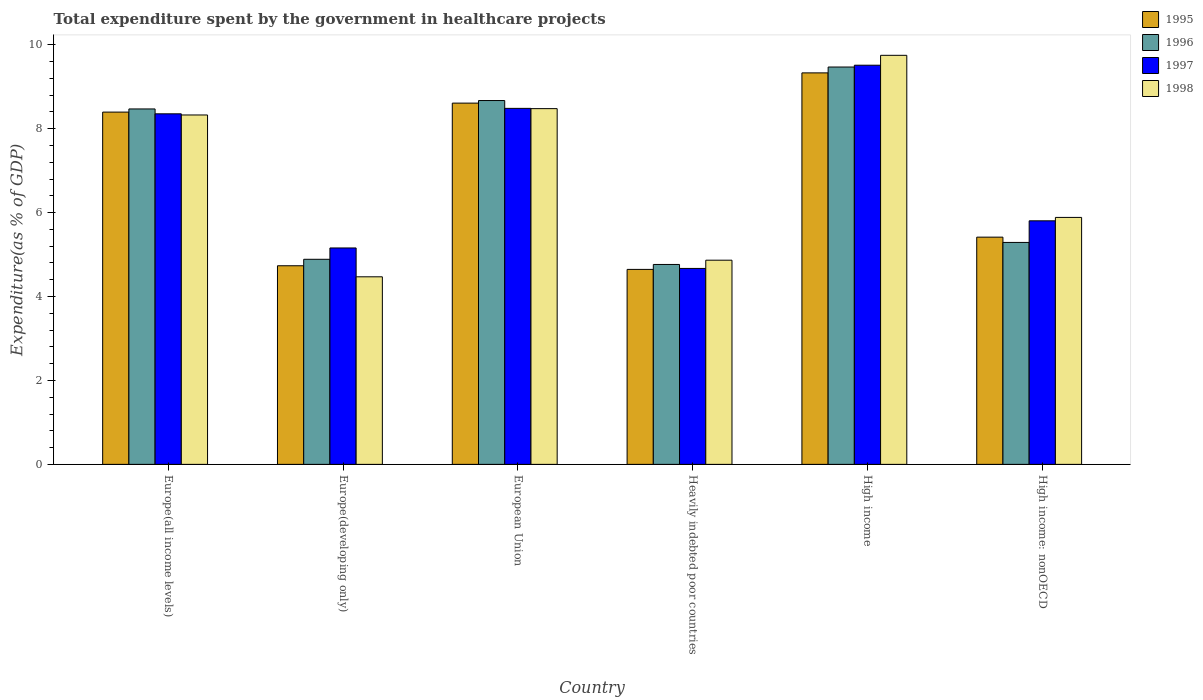How many bars are there on the 4th tick from the left?
Keep it short and to the point. 4. How many bars are there on the 2nd tick from the right?
Give a very brief answer. 4. What is the label of the 1st group of bars from the left?
Your answer should be compact. Europe(all income levels). In how many cases, is the number of bars for a given country not equal to the number of legend labels?
Your response must be concise. 0. What is the total expenditure spent by the government in healthcare projects in 1997 in High income?
Offer a terse response. 9.51. Across all countries, what is the maximum total expenditure spent by the government in healthcare projects in 1997?
Your response must be concise. 9.51. Across all countries, what is the minimum total expenditure spent by the government in healthcare projects in 1998?
Your answer should be compact. 4.47. In which country was the total expenditure spent by the government in healthcare projects in 1995 minimum?
Make the answer very short. Heavily indebted poor countries. What is the total total expenditure spent by the government in healthcare projects in 1998 in the graph?
Your answer should be very brief. 41.77. What is the difference between the total expenditure spent by the government in healthcare projects in 1998 in Europe(developing only) and that in High income: nonOECD?
Provide a succinct answer. -1.42. What is the difference between the total expenditure spent by the government in healthcare projects in 1997 in Europe(all income levels) and the total expenditure spent by the government in healthcare projects in 1995 in Europe(developing only)?
Give a very brief answer. 3.62. What is the average total expenditure spent by the government in healthcare projects in 1998 per country?
Your response must be concise. 6.96. What is the difference between the total expenditure spent by the government in healthcare projects of/in 1996 and total expenditure spent by the government in healthcare projects of/in 1997 in Europe(all income levels)?
Your answer should be very brief. 0.12. What is the ratio of the total expenditure spent by the government in healthcare projects in 1995 in Heavily indebted poor countries to that in High income: nonOECD?
Your response must be concise. 0.86. Is the difference between the total expenditure spent by the government in healthcare projects in 1996 in High income and High income: nonOECD greater than the difference between the total expenditure spent by the government in healthcare projects in 1997 in High income and High income: nonOECD?
Provide a short and direct response. Yes. What is the difference between the highest and the second highest total expenditure spent by the government in healthcare projects in 1998?
Keep it short and to the point. -1.27. What is the difference between the highest and the lowest total expenditure spent by the government in healthcare projects in 1997?
Your answer should be compact. 4.84. In how many countries, is the total expenditure spent by the government in healthcare projects in 1995 greater than the average total expenditure spent by the government in healthcare projects in 1995 taken over all countries?
Your response must be concise. 3. Is it the case that in every country, the sum of the total expenditure spent by the government in healthcare projects in 1995 and total expenditure spent by the government in healthcare projects in 1997 is greater than the sum of total expenditure spent by the government in healthcare projects in 1996 and total expenditure spent by the government in healthcare projects in 1998?
Offer a terse response. No. Is it the case that in every country, the sum of the total expenditure spent by the government in healthcare projects in 1998 and total expenditure spent by the government in healthcare projects in 1996 is greater than the total expenditure spent by the government in healthcare projects in 1997?
Make the answer very short. Yes. How many bars are there?
Your answer should be compact. 24. Does the graph contain any zero values?
Keep it short and to the point. No. Does the graph contain grids?
Make the answer very short. No. Where does the legend appear in the graph?
Give a very brief answer. Top right. How are the legend labels stacked?
Make the answer very short. Vertical. What is the title of the graph?
Your response must be concise. Total expenditure spent by the government in healthcare projects. Does "1982" appear as one of the legend labels in the graph?
Your answer should be compact. No. What is the label or title of the X-axis?
Keep it short and to the point. Country. What is the label or title of the Y-axis?
Ensure brevity in your answer.  Expenditure(as % of GDP). What is the Expenditure(as % of GDP) in 1995 in Europe(all income levels)?
Offer a terse response. 8.39. What is the Expenditure(as % of GDP) of 1996 in Europe(all income levels)?
Provide a short and direct response. 8.47. What is the Expenditure(as % of GDP) in 1997 in Europe(all income levels)?
Provide a succinct answer. 8.35. What is the Expenditure(as % of GDP) of 1998 in Europe(all income levels)?
Ensure brevity in your answer.  8.33. What is the Expenditure(as % of GDP) in 1995 in Europe(developing only)?
Offer a very short reply. 4.73. What is the Expenditure(as % of GDP) in 1996 in Europe(developing only)?
Offer a terse response. 4.89. What is the Expenditure(as % of GDP) in 1997 in Europe(developing only)?
Offer a very short reply. 5.16. What is the Expenditure(as % of GDP) in 1998 in Europe(developing only)?
Your answer should be compact. 4.47. What is the Expenditure(as % of GDP) of 1995 in European Union?
Keep it short and to the point. 8.61. What is the Expenditure(as % of GDP) in 1996 in European Union?
Give a very brief answer. 8.67. What is the Expenditure(as % of GDP) of 1997 in European Union?
Give a very brief answer. 8.48. What is the Expenditure(as % of GDP) in 1998 in European Union?
Your answer should be compact. 8.48. What is the Expenditure(as % of GDP) in 1995 in Heavily indebted poor countries?
Provide a short and direct response. 4.65. What is the Expenditure(as % of GDP) in 1996 in Heavily indebted poor countries?
Give a very brief answer. 4.76. What is the Expenditure(as % of GDP) in 1997 in Heavily indebted poor countries?
Offer a terse response. 4.67. What is the Expenditure(as % of GDP) of 1998 in Heavily indebted poor countries?
Keep it short and to the point. 4.87. What is the Expenditure(as % of GDP) in 1995 in High income?
Your response must be concise. 9.33. What is the Expenditure(as % of GDP) in 1996 in High income?
Provide a succinct answer. 9.47. What is the Expenditure(as % of GDP) of 1997 in High income?
Provide a short and direct response. 9.51. What is the Expenditure(as % of GDP) of 1998 in High income?
Your answer should be compact. 9.75. What is the Expenditure(as % of GDP) in 1995 in High income: nonOECD?
Keep it short and to the point. 5.41. What is the Expenditure(as % of GDP) in 1996 in High income: nonOECD?
Keep it short and to the point. 5.29. What is the Expenditure(as % of GDP) of 1997 in High income: nonOECD?
Provide a short and direct response. 5.8. What is the Expenditure(as % of GDP) of 1998 in High income: nonOECD?
Your answer should be compact. 5.88. Across all countries, what is the maximum Expenditure(as % of GDP) of 1995?
Your answer should be compact. 9.33. Across all countries, what is the maximum Expenditure(as % of GDP) of 1996?
Provide a succinct answer. 9.47. Across all countries, what is the maximum Expenditure(as % of GDP) of 1997?
Give a very brief answer. 9.51. Across all countries, what is the maximum Expenditure(as % of GDP) of 1998?
Provide a short and direct response. 9.75. Across all countries, what is the minimum Expenditure(as % of GDP) of 1995?
Offer a very short reply. 4.65. Across all countries, what is the minimum Expenditure(as % of GDP) in 1996?
Ensure brevity in your answer.  4.76. Across all countries, what is the minimum Expenditure(as % of GDP) in 1997?
Provide a succinct answer. 4.67. Across all countries, what is the minimum Expenditure(as % of GDP) in 1998?
Your response must be concise. 4.47. What is the total Expenditure(as % of GDP) in 1995 in the graph?
Give a very brief answer. 41.13. What is the total Expenditure(as % of GDP) of 1996 in the graph?
Your response must be concise. 41.55. What is the total Expenditure(as % of GDP) in 1997 in the graph?
Give a very brief answer. 41.98. What is the total Expenditure(as % of GDP) in 1998 in the graph?
Provide a succinct answer. 41.77. What is the difference between the Expenditure(as % of GDP) of 1995 in Europe(all income levels) and that in Europe(developing only)?
Ensure brevity in your answer.  3.66. What is the difference between the Expenditure(as % of GDP) in 1996 in Europe(all income levels) and that in Europe(developing only)?
Make the answer very short. 3.58. What is the difference between the Expenditure(as % of GDP) in 1997 in Europe(all income levels) and that in Europe(developing only)?
Provide a short and direct response. 3.2. What is the difference between the Expenditure(as % of GDP) in 1998 in Europe(all income levels) and that in Europe(developing only)?
Make the answer very short. 3.86. What is the difference between the Expenditure(as % of GDP) in 1995 in Europe(all income levels) and that in European Union?
Offer a very short reply. -0.21. What is the difference between the Expenditure(as % of GDP) of 1996 in Europe(all income levels) and that in European Union?
Keep it short and to the point. -0.2. What is the difference between the Expenditure(as % of GDP) in 1997 in Europe(all income levels) and that in European Union?
Your answer should be compact. -0.13. What is the difference between the Expenditure(as % of GDP) of 1998 in Europe(all income levels) and that in European Union?
Ensure brevity in your answer.  -0.15. What is the difference between the Expenditure(as % of GDP) of 1995 in Europe(all income levels) and that in Heavily indebted poor countries?
Make the answer very short. 3.75. What is the difference between the Expenditure(as % of GDP) of 1996 in Europe(all income levels) and that in Heavily indebted poor countries?
Your response must be concise. 3.71. What is the difference between the Expenditure(as % of GDP) in 1997 in Europe(all income levels) and that in Heavily indebted poor countries?
Provide a succinct answer. 3.68. What is the difference between the Expenditure(as % of GDP) in 1998 in Europe(all income levels) and that in Heavily indebted poor countries?
Ensure brevity in your answer.  3.46. What is the difference between the Expenditure(as % of GDP) in 1995 in Europe(all income levels) and that in High income?
Your answer should be compact. -0.93. What is the difference between the Expenditure(as % of GDP) in 1996 in Europe(all income levels) and that in High income?
Give a very brief answer. -1. What is the difference between the Expenditure(as % of GDP) in 1997 in Europe(all income levels) and that in High income?
Ensure brevity in your answer.  -1.16. What is the difference between the Expenditure(as % of GDP) in 1998 in Europe(all income levels) and that in High income?
Provide a short and direct response. -1.42. What is the difference between the Expenditure(as % of GDP) of 1995 in Europe(all income levels) and that in High income: nonOECD?
Offer a terse response. 2.98. What is the difference between the Expenditure(as % of GDP) in 1996 in Europe(all income levels) and that in High income: nonOECD?
Your response must be concise. 3.18. What is the difference between the Expenditure(as % of GDP) in 1997 in Europe(all income levels) and that in High income: nonOECD?
Your answer should be very brief. 2.55. What is the difference between the Expenditure(as % of GDP) in 1998 in Europe(all income levels) and that in High income: nonOECD?
Provide a succinct answer. 2.44. What is the difference between the Expenditure(as % of GDP) of 1995 in Europe(developing only) and that in European Union?
Your response must be concise. -3.88. What is the difference between the Expenditure(as % of GDP) in 1996 in Europe(developing only) and that in European Union?
Keep it short and to the point. -3.78. What is the difference between the Expenditure(as % of GDP) of 1997 in Europe(developing only) and that in European Union?
Give a very brief answer. -3.33. What is the difference between the Expenditure(as % of GDP) in 1998 in Europe(developing only) and that in European Union?
Offer a terse response. -4.01. What is the difference between the Expenditure(as % of GDP) of 1995 in Europe(developing only) and that in Heavily indebted poor countries?
Give a very brief answer. 0.09. What is the difference between the Expenditure(as % of GDP) in 1996 in Europe(developing only) and that in Heavily indebted poor countries?
Provide a short and direct response. 0.12. What is the difference between the Expenditure(as % of GDP) in 1997 in Europe(developing only) and that in Heavily indebted poor countries?
Your response must be concise. 0.49. What is the difference between the Expenditure(as % of GDP) in 1998 in Europe(developing only) and that in Heavily indebted poor countries?
Your response must be concise. -0.4. What is the difference between the Expenditure(as % of GDP) in 1995 in Europe(developing only) and that in High income?
Make the answer very short. -4.6. What is the difference between the Expenditure(as % of GDP) in 1996 in Europe(developing only) and that in High income?
Offer a terse response. -4.58. What is the difference between the Expenditure(as % of GDP) of 1997 in Europe(developing only) and that in High income?
Provide a succinct answer. -4.35. What is the difference between the Expenditure(as % of GDP) of 1998 in Europe(developing only) and that in High income?
Your response must be concise. -5.28. What is the difference between the Expenditure(as % of GDP) in 1995 in Europe(developing only) and that in High income: nonOECD?
Your response must be concise. -0.68. What is the difference between the Expenditure(as % of GDP) of 1996 in Europe(developing only) and that in High income: nonOECD?
Offer a terse response. -0.4. What is the difference between the Expenditure(as % of GDP) of 1997 in Europe(developing only) and that in High income: nonOECD?
Keep it short and to the point. -0.65. What is the difference between the Expenditure(as % of GDP) in 1998 in Europe(developing only) and that in High income: nonOECD?
Your answer should be compact. -1.42. What is the difference between the Expenditure(as % of GDP) of 1995 in European Union and that in Heavily indebted poor countries?
Give a very brief answer. 3.96. What is the difference between the Expenditure(as % of GDP) of 1996 in European Union and that in Heavily indebted poor countries?
Your answer should be compact. 3.91. What is the difference between the Expenditure(as % of GDP) of 1997 in European Union and that in Heavily indebted poor countries?
Your response must be concise. 3.81. What is the difference between the Expenditure(as % of GDP) of 1998 in European Union and that in Heavily indebted poor countries?
Make the answer very short. 3.61. What is the difference between the Expenditure(as % of GDP) of 1995 in European Union and that in High income?
Your answer should be very brief. -0.72. What is the difference between the Expenditure(as % of GDP) in 1996 in European Union and that in High income?
Your response must be concise. -0.8. What is the difference between the Expenditure(as % of GDP) in 1997 in European Union and that in High income?
Provide a short and direct response. -1.03. What is the difference between the Expenditure(as % of GDP) in 1998 in European Union and that in High income?
Make the answer very short. -1.27. What is the difference between the Expenditure(as % of GDP) in 1995 in European Union and that in High income: nonOECD?
Make the answer very short. 3.19. What is the difference between the Expenditure(as % of GDP) of 1996 in European Union and that in High income: nonOECD?
Offer a very short reply. 3.38. What is the difference between the Expenditure(as % of GDP) of 1997 in European Union and that in High income: nonOECD?
Give a very brief answer. 2.68. What is the difference between the Expenditure(as % of GDP) in 1998 in European Union and that in High income: nonOECD?
Provide a short and direct response. 2.59. What is the difference between the Expenditure(as % of GDP) in 1995 in Heavily indebted poor countries and that in High income?
Your answer should be very brief. -4.68. What is the difference between the Expenditure(as % of GDP) of 1996 in Heavily indebted poor countries and that in High income?
Offer a terse response. -4.7. What is the difference between the Expenditure(as % of GDP) in 1997 in Heavily indebted poor countries and that in High income?
Ensure brevity in your answer.  -4.84. What is the difference between the Expenditure(as % of GDP) in 1998 in Heavily indebted poor countries and that in High income?
Your answer should be compact. -4.88. What is the difference between the Expenditure(as % of GDP) of 1995 in Heavily indebted poor countries and that in High income: nonOECD?
Your answer should be very brief. -0.77. What is the difference between the Expenditure(as % of GDP) of 1996 in Heavily indebted poor countries and that in High income: nonOECD?
Provide a succinct answer. -0.53. What is the difference between the Expenditure(as % of GDP) of 1997 in Heavily indebted poor countries and that in High income: nonOECD?
Your answer should be very brief. -1.13. What is the difference between the Expenditure(as % of GDP) of 1998 in Heavily indebted poor countries and that in High income: nonOECD?
Offer a very short reply. -1.02. What is the difference between the Expenditure(as % of GDP) of 1995 in High income and that in High income: nonOECD?
Provide a succinct answer. 3.91. What is the difference between the Expenditure(as % of GDP) in 1996 in High income and that in High income: nonOECD?
Your answer should be compact. 4.18. What is the difference between the Expenditure(as % of GDP) of 1997 in High income and that in High income: nonOECD?
Your answer should be compact. 3.71. What is the difference between the Expenditure(as % of GDP) in 1998 in High income and that in High income: nonOECD?
Give a very brief answer. 3.86. What is the difference between the Expenditure(as % of GDP) of 1995 in Europe(all income levels) and the Expenditure(as % of GDP) of 1996 in Europe(developing only)?
Offer a terse response. 3.51. What is the difference between the Expenditure(as % of GDP) in 1995 in Europe(all income levels) and the Expenditure(as % of GDP) in 1997 in Europe(developing only)?
Make the answer very short. 3.24. What is the difference between the Expenditure(as % of GDP) in 1995 in Europe(all income levels) and the Expenditure(as % of GDP) in 1998 in Europe(developing only)?
Ensure brevity in your answer.  3.92. What is the difference between the Expenditure(as % of GDP) in 1996 in Europe(all income levels) and the Expenditure(as % of GDP) in 1997 in Europe(developing only)?
Provide a succinct answer. 3.31. What is the difference between the Expenditure(as % of GDP) in 1996 in Europe(all income levels) and the Expenditure(as % of GDP) in 1998 in Europe(developing only)?
Provide a succinct answer. 4. What is the difference between the Expenditure(as % of GDP) in 1997 in Europe(all income levels) and the Expenditure(as % of GDP) in 1998 in Europe(developing only)?
Your response must be concise. 3.88. What is the difference between the Expenditure(as % of GDP) in 1995 in Europe(all income levels) and the Expenditure(as % of GDP) in 1996 in European Union?
Provide a succinct answer. -0.28. What is the difference between the Expenditure(as % of GDP) of 1995 in Europe(all income levels) and the Expenditure(as % of GDP) of 1997 in European Union?
Provide a short and direct response. -0.09. What is the difference between the Expenditure(as % of GDP) in 1995 in Europe(all income levels) and the Expenditure(as % of GDP) in 1998 in European Union?
Provide a short and direct response. -0.08. What is the difference between the Expenditure(as % of GDP) of 1996 in Europe(all income levels) and the Expenditure(as % of GDP) of 1997 in European Union?
Your answer should be very brief. -0.01. What is the difference between the Expenditure(as % of GDP) in 1996 in Europe(all income levels) and the Expenditure(as % of GDP) in 1998 in European Union?
Ensure brevity in your answer.  -0.01. What is the difference between the Expenditure(as % of GDP) of 1997 in Europe(all income levels) and the Expenditure(as % of GDP) of 1998 in European Union?
Ensure brevity in your answer.  -0.12. What is the difference between the Expenditure(as % of GDP) in 1995 in Europe(all income levels) and the Expenditure(as % of GDP) in 1996 in Heavily indebted poor countries?
Ensure brevity in your answer.  3.63. What is the difference between the Expenditure(as % of GDP) in 1995 in Europe(all income levels) and the Expenditure(as % of GDP) in 1997 in Heavily indebted poor countries?
Your response must be concise. 3.73. What is the difference between the Expenditure(as % of GDP) in 1995 in Europe(all income levels) and the Expenditure(as % of GDP) in 1998 in Heavily indebted poor countries?
Provide a short and direct response. 3.53. What is the difference between the Expenditure(as % of GDP) in 1996 in Europe(all income levels) and the Expenditure(as % of GDP) in 1997 in Heavily indebted poor countries?
Provide a succinct answer. 3.8. What is the difference between the Expenditure(as % of GDP) in 1996 in Europe(all income levels) and the Expenditure(as % of GDP) in 1998 in Heavily indebted poor countries?
Provide a short and direct response. 3.6. What is the difference between the Expenditure(as % of GDP) in 1997 in Europe(all income levels) and the Expenditure(as % of GDP) in 1998 in Heavily indebted poor countries?
Make the answer very short. 3.49. What is the difference between the Expenditure(as % of GDP) of 1995 in Europe(all income levels) and the Expenditure(as % of GDP) of 1996 in High income?
Your response must be concise. -1.07. What is the difference between the Expenditure(as % of GDP) of 1995 in Europe(all income levels) and the Expenditure(as % of GDP) of 1997 in High income?
Offer a terse response. -1.12. What is the difference between the Expenditure(as % of GDP) of 1995 in Europe(all income levels) and the Expenditure(as % of GDP) of 1998 in High income?
Ensure brevity in your answer.  -1.35. What is the difference between the Expenditure(as % of GDP) of 1996 in Europe(all income levels) and the Expenditure(as % of GDP) of 1997 in High income?
Offer a very short reply. -1.04. What is the difference between the Expenditure(as % of GDP) of 1996 in Europe(all income levels) and the Expenditure(as % of GDP) of 1998 in High income?
Provide a short and direct response. -1.28. What is the difference between the Expenditure(as % of GDP) in 1997 in Europe(all income levels) and the Expenditure(as % of GDP) in 1998 in High income?
Offer a very short reply. -1.39. What is the difference between the Expenditure(as % of GDP) in 1995 in Europe(all income levels) and the Expenditure(as % of GDP) in 1996 in High income: nonOECD?
Offer a very short reply. 3.11. What is the difference between the Expenditure(as % of GDP) of 1995 in Europe(all income levels) and the Expenditure(as % of GDP) of 1997 in High income: nonOECD?
Provide a succinct answer. 2.59. What is the difference between the Expenditure(as % of GDP) in 1995 in Europe(all income levels) and the Expenditure(as % of GDP) in 1998 in High income: nonOECD?
Offer a very short reply. 2.51. What is the difference between the Expenditure(as % of GDP) in 1996 in Europe(all income levels) and the Expenditure(as % of GDP) in 1997 in High income: nonOECD?
Offer a very short reply. 2.67. What is the difference between the Expenditure(as % of GDP) of 1996 in Europe(all income levels) and the Expenditure(as % of GDP) of 1998 in High income: nonOECD?
Give a very brief answer. 2.58. What is the difference between the Expenditure(as % of GDP) in 1997 in Europe(all income levels) and the Expenditure(as % of GDP) in 1998 in High income: nonOECD?
Ensure brevity in your answer.  2.47. What is the difference between the Expenditure(as % of GDP) of 1995 in Europe(developing only) and the Expenditure(as % of GDP) of 1996 in European Union?
Your answer should be compact. -3.94. What is the difference between the Expenditure(as % of GDP) of 1995 in Europe(developing only) and the Expenditure(as % of GDP) of 1997 in European Union?
Provide a succinct answer. -3.75. What is the difference between the Expenditure(as % of GDP) of 1995 in Europe(developing only) and the Expenditure(as % of GDP) of 1998 in European Union?
Offer a terse response. -3.74. What is the difference between the Expenditure(as % of GDP) in 1996 in Europe(developing only) and the Expenditure(as % of GDP) in 1997 in European Union?
Offer a terse response. -3.6. What is the difference between the Expenditure(as % of GDP) in 1996 in Europe(developing only) and the Expenditure(as % of GDP) in 1998 in European Union?
Provide a succinct answer. -3.59. What is the difference between the Expenditure(as % of GDP) in 1997 in Europe(developing only) and the Expenditure(as % of GDP) in 1998 in European Union?
Your answer should be compact. -3.32. What is the difference between the Expenditure(as % of GDP) of 1995 in Europe(developing only) and the Expenditure(as % of GDP) of 1996 in Heavily indebted poor countries?
Your answer should be compact. -0.03. What is the difference between the Expenditure(as % of GDP) of 1995 in Europe(developing only) and the Expenditure(as % of GDP) of 1997 in Heavily indebted poor countries?
Your response must be concise. 0.06. What is the difference between the Expenditure(as % of GDP) of 1995 in Europe(developing only) and the Expenditure(as % of GDP) of 1998 in Heavily indebted poor countries?
Offer a very short reply. -0.13. What is the difference between the Expenditure(as % of GDP) of 1996 in Europe(developing only) and the Expenditure(as % of GDP) of 1997 in Heavily indebted poor countries?
Your answer should be compact. 0.22. What is the difference between the Expenditure(as % of GDP) of 1996 in Europe(developing only) and the Expenditure(as % of GDP) of 1998 in Heavily indebted poor countries?
Your answer should be very brief. 0.02. What is the difference between the Expenditure(as % of GDP) in 1997 in Europe(developing only) and the Expenditure(as % of GDP) in 1998 in Heavily indebted poor countries?
Provide a short and direct response. 0.29. What is the difference between the Expenditure(as % of GDP) of 1995 in Europe(developing only) and the Expenditure(as % of GDP) of 1996 in High income?
Make the answer very short. -4.74. What is the difference between the Expenditure(as % of GDP) in 1995 in Europe(developing only) and the Expenditure(as % of GDP) in 1997 in High income?
Make the answer very short. -4.78. What is the difference between the Expenditure(as % of GDP) in 1995 in Europe(developing only) and the Expenditure(as % of GDP) in 1998 in High income?
Your response must be concise. -5.01. What is the difference between the Expenditure(as % of GDP) of 1996 in Europe(developing only) and the Expenditure(as % of GDP) of 1997 in High income?
Your answer should be very brief. -4.62. What is the difference between the Expenditure(as % of GDP) of 1996 in Europe(developing only) and the Expenditure(as % of GDP) of 1998 in High income?
Ensure brevity in your answer.  -4.86. What is the difference between the Expenditure(as % of GDP) in 1997 in Europe(developing only) and the Expenditure(as % of GDP) in 1998 in High income?
Keep it short and to the point. -4.59. What is the difference between the Expenditure(as % of GDP) of 1995 in Europe(developing only) and the Expenditure(as % of GDP) of 1996 in High income: nonOECD?
Provide a short and direct response. -0.56. What is the difference between the Expenditure(as % of GDP) of 1995 in Europe(developing only) and the Expenditure(as % of GDP) of 1997 in High income: nonOECD?
Give a very brief answer. -1.07. What is the difference between the Expenditure(as % of GDP) in 1995 in Europe(developing only) and the Expenditure(as % of GDP) in 1998 in High income: nonOECD?
Provide a succinct answer. -1.15. What is the difference between the Expenditure(as % of GDP) of 1996 in Europe(developing only) and the Expenditure(as % of GDP) of 1997 in High income: nonOECD?
Your answer should be very brief. -0.92. What is the difference between the Expenditure(as % of GDP) of 1996 in Europe(developing only) and the Expenditure(as % of GDP) of 1998 in High income: nonOECD?
Keep it short and to the point. -1. What is the difference between the Expenditure(as % of GDP) in 1997 in Europe(developing only) and the Expenditure(as % of GDP) in 1998 in High income: nonOECD?
Provide a succinct answer. -0.73. What is the difference between the Expenditure(as % of GDP) in 1995 in European Union and the Expenditure(as % of GDP) in 1996 in Heavily indebted poor countries?
Provide a short and direct response. 3.84. What is the difference between the Expenditure(as % of GDP) in 1995 in European Union and the Expenditure(as % of GDP) in 1997 in Heavily indebted poor countries?
Offer a very short reply. 3.94. What is the difference between the Expenditure(as % of GDP) in 1995 in European Union and the Expenditure(as % of GDP) in 1998 in Heavily indebted poor countries?
Ensure brevity in your answer.  3.74. What is the difference between the Expenditure(as % of GDP) of 1996 in European Union and the Expenditure(as % of GDP) of 1997 in Heavily indebted poor countries?
Provide a succinct answer. 4. What is the difference between the Expenditure(as % of GDP) in 1996 in European Union and the Expenditure(as % of GDP) in 1998 in Heavily indebted poor countries?
Give a very brief answer. 3.8. What is the difference between the Expenditure(as % of GDP) of 1997 in European Union and the Expenditure(as % of GDP) of 1998 in Heavily indebted poor countries?
Provide a succinct answer. 3.62. What is the difference between the Expenditure(as % of GDP) in 1995 in European Union and the Expenditure(as % of GDP) in 1996 in High income?
Your answer should be compact. -0.86. What is the difference between the Expenditure(as % of GDP) of 1995 in European Union and the Expenditure(as % of GDP) of 1997 in High income?
Provide a succinct answer. -0.9. What is the difference between the Expenditure(as % of GDP) in 1995 in European Union and the Expenditure(as % of GDP) in 1998 in High income?
Your response must be concise. -1.14. What is the difference between the Expenditure(as % of GDP) of 1996 in European Union and the Expenditure(as % of GDP) of 1997 in High income?
Provide a short and direct response. -0.84. What is the difference between the Expenditure(as % of GDP) of 1996 in European Union and the Expenditure(as % of GDP) of 1998 in High income?
Ensure brevity in your answer.  -1.08. What is the difference between the Expenditure(as % of GDP) in 1997 in European Union and the Expenditure(as % of GDP) in 1998 in High income?
Make the answer very short. -1.26. What is the difference between the Expenditure(as % of GDP) of 1995 in European Union and the Expenditure(as % of GDP) of 1996 in High income: nonOECD?
Make the answer very short. 3.32. What is the difference between the Expenditure(as % of GDP) in 1995 in European Union and the Expenditure(as % of GDP) in 1997 in High income: nonOECD?
Ensure brevity in your answer.  2.8. What is the difference between the Expenditure(as % of GDP) in 1995 in European Union and the Expenditure(as % of GDP) in 1998 in High income: nonOECD?
Offer a terse response. 2.72. What is the difference between the Expenditure(as % of GDP) of 1996 in European Union and the Expenditure(as % of GDP) of 1997 in High income: nonOECD?
Offer a terse response. 2.87. What is the difference between the Expenditure(as % of GDP) of 1996 in European Union and the Expenditure(as % of GDP) of 1998 in High income: nonOECD?
Your answer should be compact. 2.79. What is the difference between the Expenditure(as % of GDP) of 1997 in European Union and the Expenditure(as % of GDP) of 1998 in High income: nonOECD?
Your response must be concise. 2.6. What is the difference between the Expenditure(as % of GDP) in 1995 in Heavily indebted poor countries and the Expenditure(as % of GDP) in 1996 in High income?
Offer a very short reply. -4.82. What is the difference between the Expenditure(as % of GDP) in 1995 in Heavily indebted poor countries and the Expenditure(as % of GDP) in 1997 in High income?
Your answer should be compact. -4.87. What is the difference between the Expenditure(as % of GDP) in 1995 in Heavily indebted poor countries and the Expenditure(as % of GDP) in 1998 in High income?
Keep it short and to the point. -5.1. What is the difference between the Expenditure(as % of GDP) in 1996 in Heavily indebted poor countries and the Expenditure(as % of GDP) in 1997 in High income?
Give a very brief answer. -4.75. What is the difference between the Expenditure(as % of GDP) in 1996 in Heavily indebted poor countries and the Expenditure(as % of GDP) in 1998 in High income?
Ensure brevity in your answer.  -4.98. What is the difference between the Expenditure(as % of GDP) in 1997 in Heavily indebted poor countries and the Expenditure(as % of GDP) in 1998 in High income?
Provide a succinct answer. -5.08. What is the difference between the Expenditure(as % of GDP) in 1995 in Heavily indebted poor countries and the Expenditure(as % of GDP) in 1996 in High income: nonOECD?
Ensure brevity in your answer.  -0.64. What is the difference between the Expenditure(as % of GDP) in 1995 in Heavily indebted poor countries and the Expenditure(as % of GDP) in 1997 in High income: nonOECD?
Give a very brief answer. -1.16. What is the difference between the Expenditure(as % of GDP) in 1995 in Heavily indebted poor countries and the Expenditure(as % of GDP) in 1998 in High income: nonOECD?
Ensure brevity in your answer.  -1.24. What is the difference between the Expenditure(as % of GDP) of 1996 in Heavily indebted poor countries and the Expenditure(as % of GDP) of 1997 in High income: nonOECD?
Your answer should be very brief. -1.04. What is the difference between the Expenditure(as % of GDP) of 1996 in Heavily indebted poor countries and the Expenditure(as % of GDP) of 1998 in High income: nonOECD?
Provide a short and direct response. -1.12. What is the difference between the Expenditure(as % of GDP) in 1997 in Heavily indebted poor countries and the Expenditure(as % of GDP) in 1998 in High income: nonOECD?
Give a very brief answer. -1.22. What is the difference between the Expenditure(as % of GDP) in 1995 in High income and the Expenditure(as % of GDP) in 1996 in High income: nonOECD?
Give a very brief answer. 4.04. What is the difference between the Expenditure(as % of GDP) of 1995 in High income and the Expenditure(as % of GDP) of 1997 in High income: nonOECD?
Your answer should be very brief. 3.53. What is the difference between the Expenditure(as % of GDP) of 1995 in High income and the Expenditure(as % of GDP) of 1998 in High income: nonOECD?
Ensure brevity in your answer.  3.44. What is the difference between the Expenditure(as % of GDP) in 1996 in High income and the Expenditure(as % of GDP) in 1997 in High income: nonOECD?
Make the answer very short. 3.66. What is the difference between the Expenditure(as % of GDP) of 1996 in High income and the Expenditure(as % of GDP) of 1998 in High income: nonOECD?
Offer a terse response. 3.58. What is the difference between the Expenditure(as % of GDP) of 1997 in High income and the Expenditure(as % of GDP) of 1998 in High income: nonOECD?
Keep it short and to the point. 3.63. What is the average Expenditure(as % of GDP) in 1995 per country?
Ensure brevity in your answer.  6.85. What is the average Expenditure(as % of GDP) in 1996 per country?
Offer a very short reply. 6.92. What is the average Expenditure(as % of GDP) of 1997 per country?
Offer a very short reply. 7. What is the average Expenditure(as % of GDP) in 1998 per country?
Ensure brevity in your answer.  6.96. What is the difference between the Expenditure(as % of GDP) of 1995 and Expenditure(as % of GDP) of 1996 in Europe(all income levels)?
Your response must be concise. -0.07. What is the difference between the Expenditure(as % of GDP) of 1995 and Expenditure(as % of GDP) of 1997 in Europe(all income levels)?
Make the answer very short. 0.04. What is the difference between the Expenditure(as % of GDP) of 1995 and Expenditure(as % of GDP) of 1998 in Europe(all income levels)?
Your response must be concise. 0.07. What is the difference between the Expenditure(as % of GDP) in 1996 and Expenditure(as % of GDP) in 1997 in Europe(all income levels)?
Keep it short and to the point. 0.12. What is the difference between the Expenditure(as % of GDP) in 1996 and Expenditure(as % of GDP) in 1998 in Europe(all income levels)?
Your answer should be compact. 0.14. What is the difference between the Expenditure(as % of GDP) of 1997 and Expenditure(as % of GDP) of 1998 in Europe(all income levels)?
Provide a succinct answer. 0.03. What is the difference between the Expenditure(as % of GDP) in 1995 and Expenditure(as % of GDP) in 1996 in Europe(developing only)?
Your answer should be very brief. -0.15. What is the difference between the Expenditure(as % of GDP) in 1995 and Expenditure(as % of GDP) in 1997 in Europe(developing only)?
Offer a terse response. -0.42. What is the difference between the Expenditure(as % of GDP) of 1995 and Expenditure(as % of GDP) of 1998 in Europe(developing only)?
Offer a very short reply. 0.26. What is the difference between the Expenditure(as % of GDP) of 1996 and Expenditure(as % of GDP) of 1997 in Europe(developing only)?
Your answer should be compact. -0.27. What is the difference between the Expenditure(as % of GDP) of 1996 and Expenditure(as % of GDP) of 1998 in Europe(developing only)?
Your response must be concise. 0.42. What is the difference between the Expenditure(as % of GDP) in 1997 and Expenditure(as % of GDP) in 1998 in Europe(developing only)?
Provide a succinct answer. 0.69. What is the difference between the Expenditure(as % of GDP) in 1995 and Expenditure(as % of GDP) in 1996 in European Union?
Keep it short and to the point. -0.06. What is the difference between the Expenditure(as % of GDP) in 1995 and Expenditure(as % of GDP) in 1997 in European Union?
Ensure brevity in your answer.  0.13. What is the difference between the Expenditure(as % of GDP) in 1995 and Expenditure(as % of GDP) in 1998 in European Union?
Your answer should be compact. 0.13. What is the difference between the Expenditure(as % of GDP) in 1996 and Expenditure(as % of GDP) in 1997 in European Union?
Provide a short and direct response. 0.19. What is the difference between the Expenditure(as % of GDP) of 1996 and Expenditure(as % of GDP) of 1998 in European Union?
Offer a very short reply. 0.19. What is the difference between the Expenditure(as % of GDP) in 1997 and Expenditure(as % of GDP) in 1998 in European Union?
Offer a terse response. 0.01. What is the difference between the Expenditure(as % of GDP) of 1995 and Expenditure(as % of GDP) of 1996 in Heavily indebted poor countries?
Provide a succinct answer. -0.12. What is the difference between the Expenditure(as % of GDP) of 1995 and Expenditure(as % of GDP) of 1997 in Heavily indebted poor countries?
Your answer should be compact. -0.02. What is the difference between the Expenditure(as % of GDP) of 1995 and Expenditure(as % of GDP) of 1998 in Heavily indebted poor countries?
Your response must be concise. -0.22. What is the difference between the Expenditure(as % of GDP) in 1996 and Expenditure(as % of GDP) in 1997 in Heavily indebted poor countries?
Offer a very short reply. 0.09. What is the difference between the Expenditure(as % of GDP) in 1996 and Expenditure(as % of GDP) in 1998 in Heavily indebted poor countries?
Give a very brief answer. -0.1. What is the difference between the Expenditure(as % of GDP) of 1997 and Expenditure(as % of GDP) of 1998 in Heavily indebted poor countries?
Your answer should be very brief. -0.2. What is the difference between the Expenditure(as % of GDP) in 1995 and Expenditure(as % of GDP) in 1996 in High income?
Offer a terse response. -0.14. What is the difference between the Expenditure(as % of GDP) of 1995 and Expenditure(as % of GDP) of 1997 in High income?
Ensure brevity in your answer.  -0.18. What is the difference between the Expenditure(as % of GDP) in 1995 and Expenditure(as % of GDP) in 1998 in High income?
Ensure brevity in your answer.  -0.42. What is the difference between the Expenditure(as % of GDP) of 1996 and Expenditure(as % of GDP) of 1997 in High income?
Provide a short and direct response. -0.04. What is the difference between the Expenditure(as % of GDP) of 1996 and Expenditure(as % of GDP) of 1998 in High income?
Provide a succinct answer. -0.28. What is the difference between the Expenditure(as % of GDP) of 1997 and Expenditure(as % of GDP) of 1998 in High income?
Offer a terse response. -0.24. What is the difference between the Expenditure(as % of GDP) of 1995 and Expenditure(as % of GDP) of 1996 in High income: nonOECD?
Offer a very short reply. 0.13. What is the difference between the Expenditure(as % of GDP) in 1995 and Expenditure(as % of GDP) in 1997 in High income: nonOECD?
Your response must be concise. -0.39. What is the difference between the Expenditure(as % of GDP) in 1995 and Expenditure(as % of GDP) in 1998 in High income: nonOECD?
Make the answer very short. -0.47. What is the difference between the Expenditure(as % of GDP) in 1996 and Expenditure(as % of GDP) in 1997 in High income: nonOECD?
Make the answer very short. -0.52. What is the difference between the Expenditure(as % of GDP) of 1996 and Expenditure(as % of GDP) of 1998 in High income: nonOECD?
Your answer should be very brief. -0.6. What is the difference between the Expenditure(as % of GDP) in 1997 and Expenditure(as % of GDP) in 1998 in High income: nonOECD?
Provide a short and direct response. -0.08. What is the ratio of the Expenditure(as % of GDP) in 1995 in Europe(all income levels) to that in Europe(developing only)?
Keep it short and to the point. 1.77. What is the ratio of the Expenditure(as % of GDP) of 1996 in Europe(all income levels) to that in Europe(developing only)?
Your answer should be compact. 1.73. What is the ratio of the Expenditure(as % of GDP) in 1997 in Europe(all income levels) to that in Europe(developing only)?
Give a very brief answer. 1.62. What is the ratio of the Expenditure(as % of GDP) of 1998 in Europe(all income levels) to that in Europe(developing only)?
Provide a succinct answer. 1.86. What is the ratio of the Expenditure(as % of GDP) in 1995 in Europe(all income levels) to that in European Union?
Make the answer very short. 0.98. What is the ratio of the Expenditure(as % of GDP) in 1996 in Europe(all income levels) to that in European Union?
Ensure brevity in your answer.  0.98. What is the ratio of the Expenditure(as % of GDP) in 1997 in Europe(all income levels) to that in European Union?
Your answer should be very brief. 0.98. What is the ratio of the Expenditure(as % of GDP) of 1998 in Europe(all income levels) to that in European Union?
Keep it short and to the point. 0.98. What is the ratio of the Expenditure(as % of GDP) of 1995 in Europe(all income levels) to that in Heavily indebted poor countries?
Your answer should be very brief. 1.81. What is the ratio of the Expenditure(as % of GDP) of 1996 in Europe(all income levels) to that in Heavily indebted poor countries?
Provide a short and direct response. 1.78. What is the ratio of the Expenditure(as % of GDP) in 1997 in Europe(all income levels) to that in Heavily indebted poor countries?
Your response must be concise. 1.79. What is the ratio of the Expenditure(as % of GDP) of 1998 in Europe(all income levels) to that in Heavily indebted poor countries?
Your response must be concise. 1.71. What is the ratio of the Expenditure(as % of GDP) of 1995 in Europe(all income levels) to that in High income?
Ensure brevity in your answer.  0.9. What is the ratio of the Expenditure(as % of GDP) in 1996 in Europe(all income levels) to that in High income?
Your answer should be very brief. 0.89. What is the ratio of the Expenditure(as % of GDP) of 1997 in Europe(all income levels) to that in High income?
Offer a very short reply. 0.88. What is the ratio of the Expenditure(as % of GDP) in 1998 in Europe(all income levels) to that in High income?
Keep it short and to the point. 0.85. What is the ratio of the Expenditure(as % of GDP) of 1995 in Europe(all income levels) to that in High income: nonOECD?
Keep it short and to the point. 1.55. What is the ratio of the Expenditure(as % of GDP) in 1996 in Europe(all income levels) to that in High income: nonOECD?
Give a very brief answer. 1.6. What is the ratio of the Expenditure(as % of GDP) of 1997 in Europe(all income levels) to that in High income: nonOECD?
Your answer should be compact. 1.44. What is the ratio of the Expenditure(as % of GDP) of 1998 in Europe(all income levels) to that in High income: nonOECD?
Provide a succinct answer. 1.41. What is the ratio of the Expenditure(as % of GDP) in 1995 in Europe(developing only) to that in European Union?
Provide a short and direct response. 0.55. What is the ratio of the Expenditure(as % of GDP) of 1996 in Europe(developing only) to that in European Union?
Provide a succinct answer. 0.56. What is the ratio of the Expenditure(as % of GDP) in 1997 in Europe(developing only) to that in European Union?
Your answer should be very brief. 0.61. What is the ratio of the Expenditure(as % of GDP) in 1998 in Europe(developing only) to that in European Union?
Offer a terse response. 0.53. What is the ratio of the Expenditure(as % of GDP) in 1995 in Europe(developing only) to that in Heavily indebted poor countries?
Give a very brief answer. 1.02. What is the ratio of the Expenditure(as % of GDP) in 1996 in Europe(developing only) to that in Heavily indebted poor countries?
Offer a very short reply. 1.03. What is the ratio of the Expenditure(as % of GDP) of 1997 in Europe(developing only) to that in Heavily indebted poor countries?
Make the answer very short. 1.1. What is the ratio of the Expenditure(as % of GDP) in 1998 in Europe(developing only) to that in Heavily indebted poor countries?
Make the answer very short. 0.92. What is the ratio of the Expenditure(as % of GDP) in 1995 in Europe(developing only) to that in High income?
Provide a succinct answer. 0.51. What is the ratio of the Expenditure(as % of GDP) of 1996 in Europe(developing only) to that in High income?
Your response must be concise. 0.52. What is the ratio of the Expenditure(as % of GDP) of 1997 in Europe(developing only) to that in High income?
Your response must be concise. 0.54. What is the ratio of the Expenditure(as % of GDP) in 1998 in Europe(developing only) to that in High income?
Give a very brief answer. 0.46. What is the ratio of the Expenditure(as % of GDP) in 1995 in Europe(developing only) to that in High income: nonOECD?
Your answer should be compact. 0.87. What is the ratio of the Expenditure(as % of GDP) of 1996 in Europe(developing only) to that in High income: nonOECD?
Keep it short and to the point. 0.92. What is the ratio of the Expenditure(as % of GDP) of 1997 in Europe(developing only) to that in High income: nonOECD?
Offer a very short reply. 0.89. What is the ratio of the Expenditure(as % of GDP) of 1998 in Europe(developing only) to that in High income: nonOECD?
Give a very brief answer. 0.76. What is the ratio of the Expenditure(as % of GDP) of 1995 in European Union to that in Heavily indebted poor countries?
Provide a short and direct response. 1.85. What is the ratio of the Expenditure(as % of GDP) of 1996 in European Union to that in Heavily indebted poor countries?
Provide a short and direct response. 1.82. What is the ratio of the Expenditure(as % of GDP) of 1997 in European Union to that in Heavily indebted poor countries?
Make the answer very short. 1.82. What is the ratio of the Expenditure(as % of GDP) in 1998 in European Union to that in Heavily indebted poor countries?
Your answer should be very brief. 1.74. What is the ratio of the Expenditure(as % of GDP) of 1995 in European Union to that in High income?
Provide a succinct answer. 0.92. What is the ratio of the Expenditure(as % of GDP) of 1996 in European Union to that in High income?
Provide a short and direct response. 0.92. What is the ratio of the Expenditure(as % of GDP) of 1997 in European Union to that in High income?
Give a very brief answer. 0.89. What is the ratio of the Expenditure(as % of GDP) in 1998 in European Union to that in High income?
Your answer should be very brief. 0.87. What is the ratio of the Expenditure(as % of GDP) of 1995 in European Union to that in High income: nonOECD?
Provide a short and direct response. 1.59. What is the ratio of the Expenditure(as % of GDP) of 1996 in European Union to that in High income: nonOECD?
Make the answer very short. 1.64. What is the ratio of the Expenditure(as % of GDP) in 1997 in European Union to that in High income: nonOECD?
Provide a short and direct response. 1.46. What is the ratio of the Expenditure(as % of GDP) of 1998 in European Union to that in High income: nonOECD?
Your response must be concise. 1.44. What is the ratio of the Expenditure(as % of GDP) of 1995 in Heavily indebted poor countries to that in High income?
Provide a short and direct response. 0.5. What is the ratio of the Expenditure(as % of GDP) in 1996 in Heavily indebted poor countries to that in High income?
Keep it short and to the point. 0.5. What is the ratio of the Expenditure(as % of GDP) in 1997 in Heavily indebted poor countries to that in High income?
Provide a succinct answer. 0.49. What is the ratio of the Expenditure(as % of GDP) in 1998 in Heavily indebted poor countries to that in High income?
Offer a very short reply. 0.5. What is the ratio of the Expenditure(as % of GDP) of 1995 in Heavily indebted poor countries to that in High income: nonOECD?
Your answer should be very brief. 0.86. What is the ratio of the Expenditure(as % of GDP) of 1996 in Heavily indebted poor countries to that in High income: nonOECD?
Ensure brevity in your answer.  0.9. What is the ratio of the Expenditure(as % of GDP) of 1997 in Heavily indebted poor countries to that in High income: nonOECD?
Offer a very short reply. 0.8. What is the ratio of the Expenditure(as % of GDP) of 1998 in Heavily indebted poor countries to that in High income: nonOECD?
Give a very brief answer. 0.83. What is the ratio of the Expenditure(as % of GDP) in 1995 in High income to that in High income: nonOECD?
Offer a terse response. 1.72. What is the ratio of the Expenditure(as % of GDP) in 1996 in High income to that in High income: nonOECD?
Your response must be concise. 1.79. What is the ratio of the Expenditure(as % of GDP) of 1997 in High income to that in High income: nonOECD?
Keep it short and to the point. 1.64. What is the ratio of the Expenditure(as % of GDP) of 1998 in High income to that in High income: nonOECD?
Provide a short and direct response. 1.66. What is the difference between the highest and the second highest Expenditure(as % of GDP) of 1995?
Provide a short and direct response. 0.72. What is the difference between the highest and the second highest Expenditure(as % of GDP) in 1996?
Give a very brief answer. 0.8. What is the difference between the highest and the second highest Expenditure(as % of GDP) of 1997?
Provide a short and direct response. 1.03. What is the difference between the highest and the second highest Expenditure(as % of GDP) in 1998?
Give a very brief answer. 1.27. What is the difference between the highest and the lowest Expenditure(as % of GDP) in 1995?
Ensure brevity in your answer.  4.68. What is the difference between the highest and the lowest Expenditure(as % of GDP) of 1996?
Ensure brevity in your answer.  4.7. What is the difference between the highest and the lowest Expenditure(as % of GDP) of 1997?
Offer a very short reply. 4.84. What is the difference between the highest and the lowest Expenditure(as % of GDP) in 1998?
Provide a short and direct response. 5.28. 